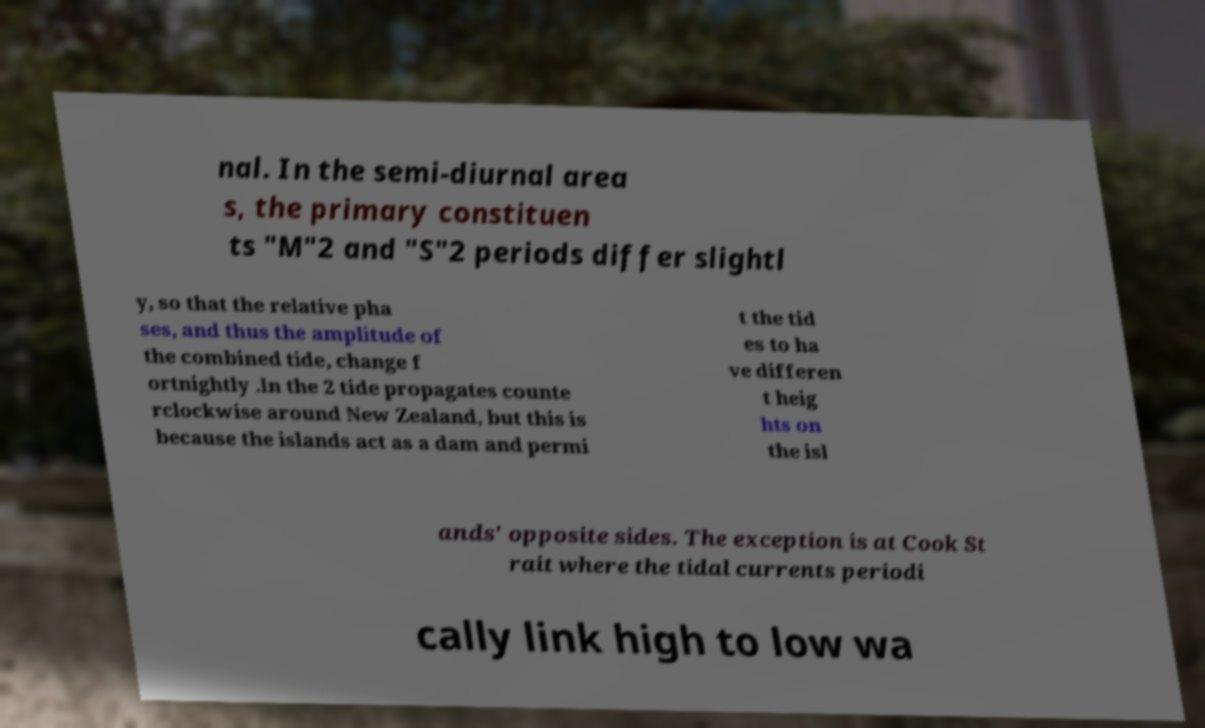Could you assist in decoding the text presented in this image and type it out clearly? nal. In the semi-diurnal area s, the primary constituen ts "M"2 and "S"2 periods differ slightl y, so that the relative pha ses, and thus the amplitude of the combined tide, change f ortnightly .In the 2 tide propagates counte rclockwise around New Zealand, but this is because the islands act as a dam and permi t the tid es to ha ve differen t heig hts on the isl ands' opposite sides. The exception is at Cook St rait where the tidal currents periodi cally link high to low wa 